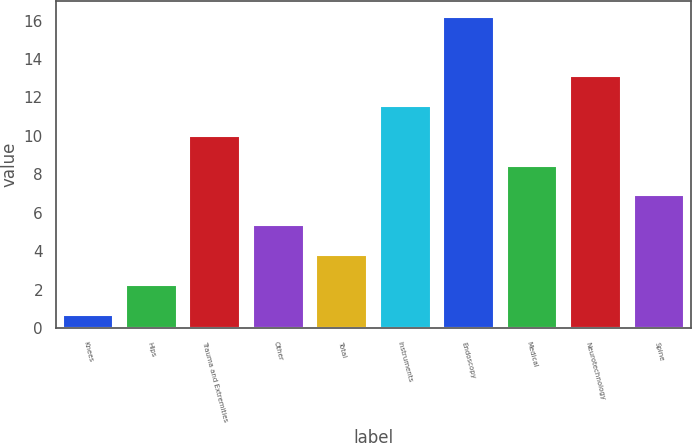Convert chart. <chart><loc_0><loc_0><loc_500><loc_500><bar_chart><fcel>Knees<fcel>Hips<fcel>Trauma and Extremities<fcel>Other<fcel>Total<fcel>Instruments<fcel>Endoscopy<fcel>Medical<fcel>Neurotechnology<fcel>Spine<nl><fcel>0.7<fcel>2.25<fcel>10<fcel>5.35<fcel>3.8<fcel>11.55<fcel>16.2<fcel>8.45<fcel>13.1<fcel>6.9<nl></chart> 